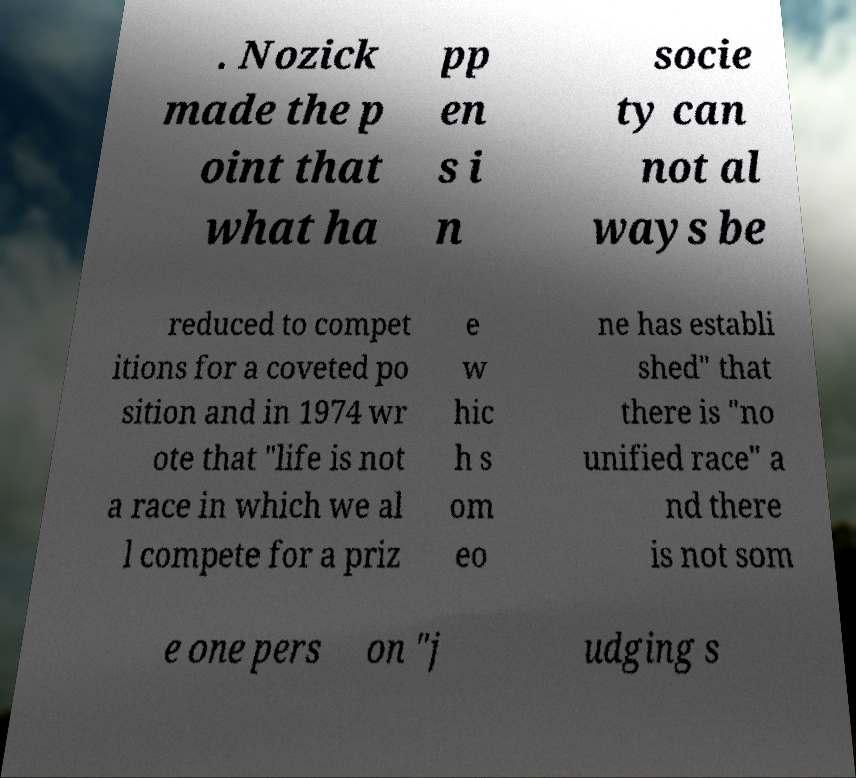There's text embedded in this image that I need extracted. Can you transcribe it verbatim? . Nozick made the p oint that what ha pp en s i n socie ty can not al ways be reduced to compet itions for a coveted po sition and in 1974 wr ote that "life is not a race in which we al l compete for a priz e w hic h s om eo ne has establi shed" that there is "no unified race" a nd there is not som e one pers on "j udging s 